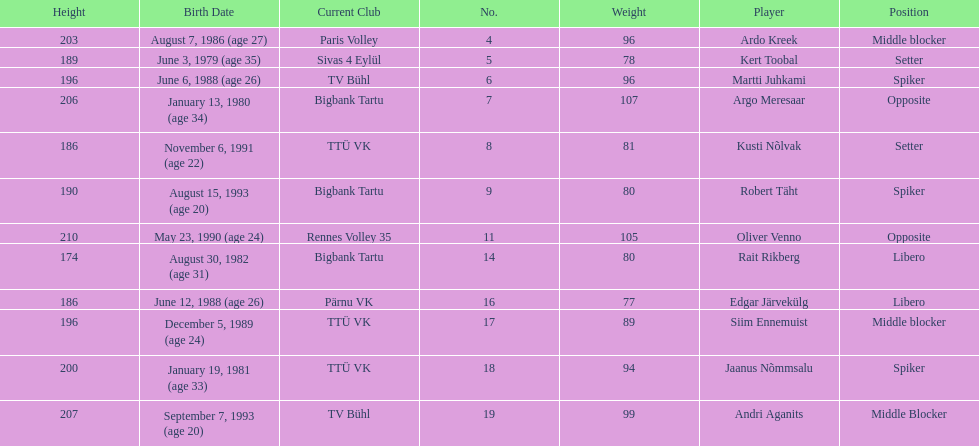Kert toobal is the oldest who is the next oldest player listed? Argo Meresaar. 